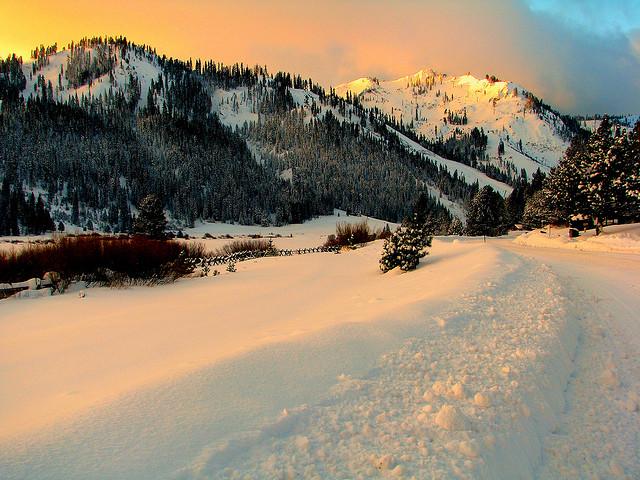Is this in Hawaii?
Write a very short answer. No. Are there tracks in the snow?
Write a very short answer. Yes. Is the sun setting?
Keep it brief. Yes. What season is it?
Short answer required. Winter. Is the Sun rising or setting?
Short answer required. Setting. Is there a horse in the picture?
Be succinct. No. 